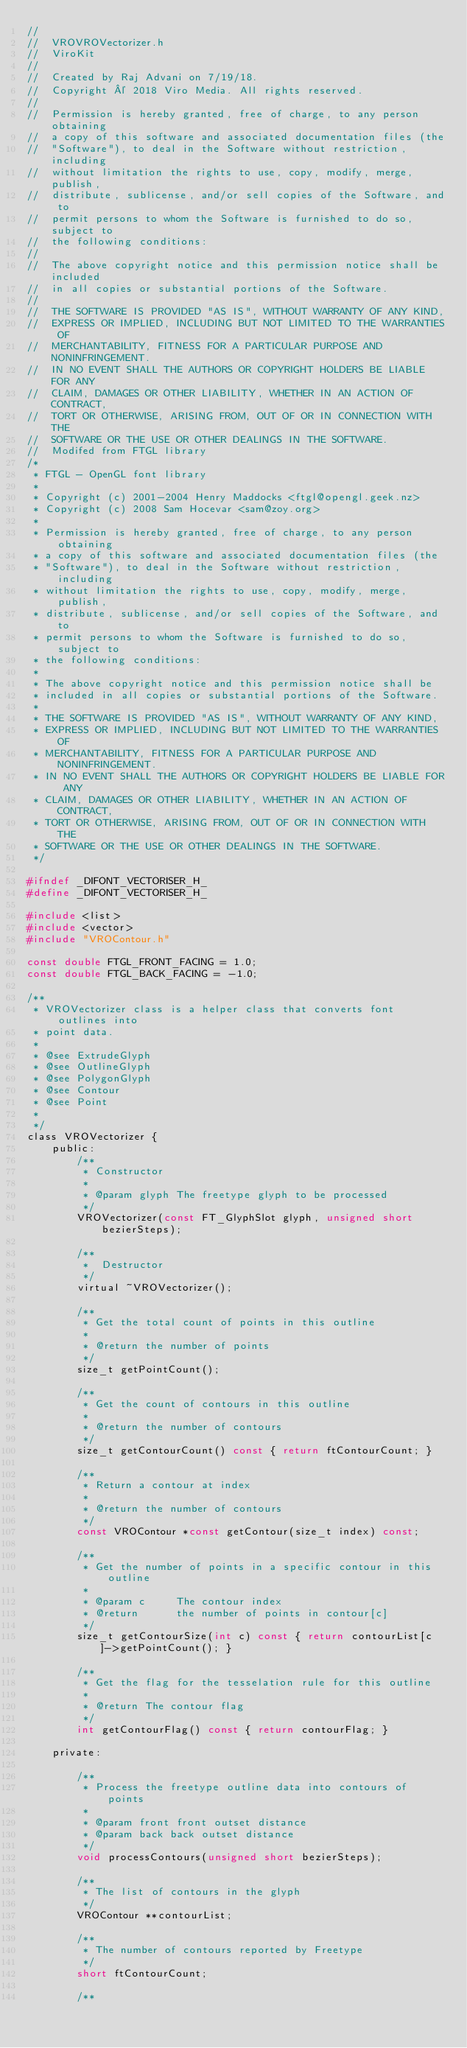<code> <loc_0><loc_0><loc_500><loc_500><_C_>//
//  VROVROVectorizer.h
//  ViroKit
//
//  Created by Raj Advani on 7/19/18.
//  Copyright © 2018 Viro Media. All rights reserved.
//
//  Permission is hereby granted, free of charge, to any person obtaining
//  a copy of this software and associated documentation files (the
//  "Software"), to deal in the Software without restriction, including
//  without limitation the rights to use, copy, modify, merge, publish,
//  distribute, sublicense, and/or sell copies of the Software, and to
//  permit persons to whom the Software is furnished to do so, subject to
//  the following conditions:
//
//  The above copyright notice and this permission notice shall be included
//  in all copies or substantial portions of the Software.
//
//  THE SOFTWARE IS PROVIDED "AS IS", WITHOUT WARRANTY OF ANY KIND,
//  EXPRESS OR IMPLIED, INCLUDING BUT NOT LIMITED TO THE WARRANTIES OF
//  MERCHANTABILITY, FITNESS FOR A PARTICULAR PURPOSE AND NONINFRINGEMENT.
//  IN NO EVENT SHALL THE AUTHORS OR COPYRIGHT HOLDERS BE LIABLE FOR ANY
//  CLAIM, DAMAGES OR OTHER LIABILITY, WHETHER IN AN ACTION OF CONTRACT,
//  TORT OR OTHERWISE, ARISING FROM, OUT OF OR IN CONNECTION WITH THE
//  SOFTWARE OR THE USE OR OTHER DEALINGS IN THE SOFTWARE.
//  Modifed from FTGL library
/*
 * FTGL - OpenGL font library
 *
 * Copyright (c) 2001-2004 Henry Maddocks <ftgl@opengl.geek.nz>
 * Copyright (c) 2008 Sam Hocevar <sam@zoy.org>
 *
 * Permission is hereby granted, free of charge, to any person obtaining
 * a copy of this software and associated documentation files (the
 * "Software"), to deal in the Software without restriction, including
 * without limitation the rights to use, copy, modify, merge, publish,
 * distribute, sublicense, and/or sell copies of the Software, and to
 * permit persons to whom the Software is furnished to do so, subject to
 * the following conditions:
 *
 * The above copyright notice and this permission notice shall be
 * included in all copies or substantial portions of the Software.
 *
 * THE SOFTWARE IS PROVIDED "AS IS", WITHOUT WARRANTY OF ANY KIND,
 * EXPRESS OR IMPLIED, INCLUDING BUT NOT LIMITED TO THE WARRANTIES OF
 * MERCHANTABILITY, FITNESS FOR A PARTICULAR PURPOSE AND NONINFRINGEMENT.
 * IN NO EVENT SHALL THE AUTHORS OR COPYRIGHT HOLDERS BE LIABLE FOR ANY
 * CLAIM, DAMAGES OR OTHER LIABILITY, WHETHER IN AN ACTION OF CONTRACT,
 * TORT OR OTHERWISE, ARISING FROM, OUT OF OR IN CONNECTION WITH THE
 * SOFTWARE OR THE USE OR OTHER DEALINGS IN THE SOFTWARE.
 */

#ifndef _DIFONT_VECTORISER_H_
#define _DIFONT_VECTORISER_H_

#include <list>
#include <vector>
#include "VROContour.h"

const double FTGL_FRONT_FACING = 1.0;
const double FTGL_BACK_FACING = -1.0;

/**
 * VROVectorizer class is a helper class that converts font outlines into
 * point data.
 *
 * @see ExtrudeGlyph
 * @see OutlineGlyph
 * @see PolygonGlyph
 * @see Contour
 * @see Point
 *
 */
class VROVectorizer {
    public:
        /**
         * Constructor
         *
         * @param glyph The freetype glyph to be processed
         */
        VROVectorizer(const FT_GlyphSlot glyph, unsigned short bezierSteps);

        /**
         *  Destructor
         */
        virtual ~VROVectorizer();

        /**
         * Get the total count of points in this outline
         *
         * @return the number of points
         */
        size_t getPointCount();

        /**
         * Get the count of contours in this outline
         *
         * @return the number of contours
         */
        size_t getContourCount() const { return ftContourCount; }

        /**
         * Return a contour at index
         *
         * @return the number of contours
         */
        const VROContour *const getContour(size_t index) const;

        /**
         * Get the number of points in a specific contour in this outline
         *
         * @param c     The contour index
         * @return      the number of points in contour[c]
         */
        size_t getContourSize(int c) const { return contourList[c]->getPointCount(); }

        /**
         * Get the flag for the tesselation rule for this outline
         *
         * @return The contour flag
         */
        int getContourFlag() const { return contourFlag; }

    private:
    
        /**
         * Process the freetype outline data into contours of points
         *
         * @param front front outset distance
         * @param back back outset distance
         */
        void processContours(unsigned short bezierSteps);

        /**
         * The list of contours in the glyph
         */
        VROContour **contourList;

        /**
         * The number of contours reported by Freetype
         */
        short ftContourCount;
        
        /**</code> 